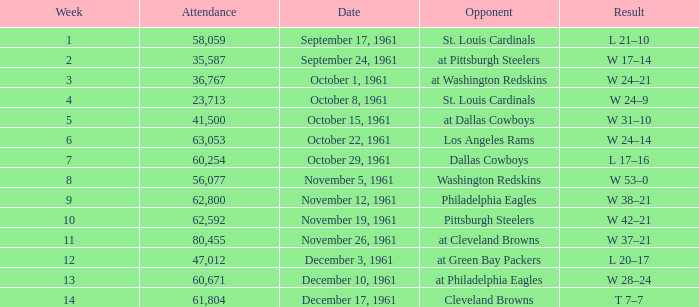Could you help me parse every detail presented in this table? {'header': ['Week', 'Attendance', 'Date', 'Opponent', 'Result'], 'rows': [['1', '58,059', 'September 17, 1961', 'St. Louis Cardinals', 'L 21–10'], ['2', '35,587', 'September 24, 1961', 'at Pittsburgh Steelers', 'W 17–14'], ['3', '36,767', 'October 1, 1961', 'at Washington Redskins', 'W 24–21'], ['4', '23,713', 'October 8, 1961', 'St. Louis Cardinals', 'W 24–9'], ['5', '41,500', 'October 15, 1961', 'at Dallas Cowboys', 'W 31–10'], ['6', '63,053', 'October 22, 1961', 'Los Angeles Rams', 'W 24–14'], ['7', '60,254', 'October 29, 1961', 'Dallas Cowboys', 'L 17–16'], ['8', '56,077', 'November 5, 1961', 'Washington Redskins', 'W 53–0'], ['9', '62,800', 'November 12, 1961', 'Philadelphia Eagles', 'W 38–21'], ['10', '62,592', 'November 19, 1961', 'Pittsburgh Steelers', 'W 42–21'], ['11', '80,455', 'November 26, 1961', 'at Cleveland Browns', 'W 37–21'], ['12', '47,012', 'December 3, 1961', 'at Green Bay Packers', 'L 20–17'], ['13', '60,671', 'December 10, 1961', 'at Philadelphia Eagles', 'W 28–24'], ['14', '61,804', 'December 17, 1961', 'Cleveland Browns', 'T 7–7']]} Which Week has an Opponent of washington redskins, and an Attendance larger than 56,077? 0.0. 